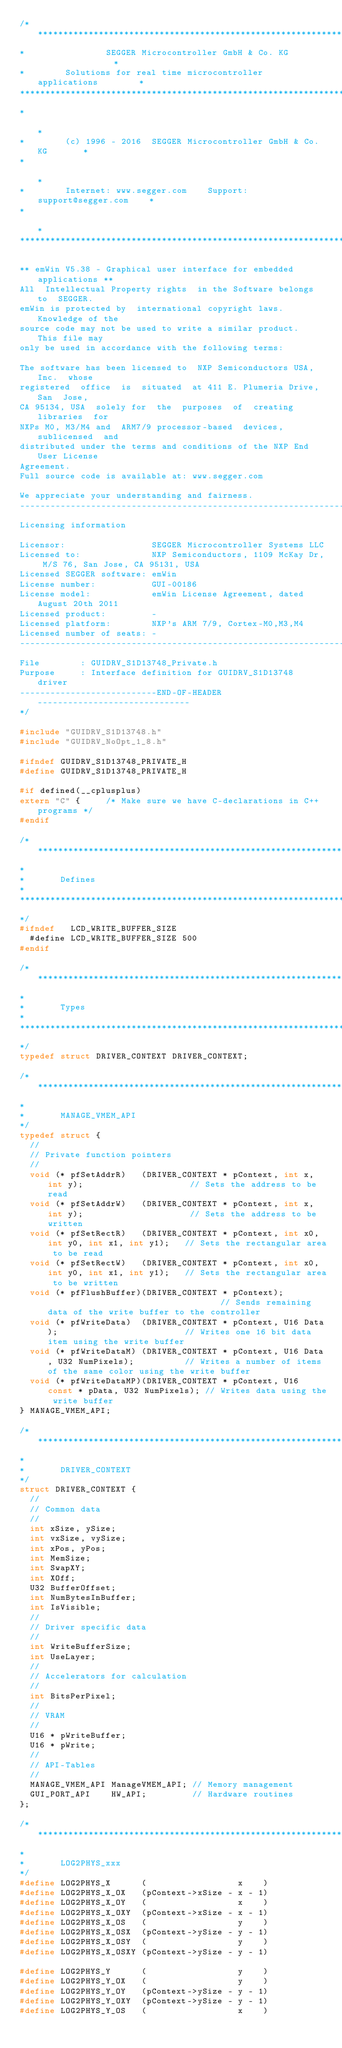<code> <loc_0><loc_0><loc_500><loc_500><_C_>/*********************************************************************
*                SEGGER Microcontroller GmbH & Co. KG                *
*        Solutions for real time microcontroller applications        *
**********************************************************************
*                                                                    *
*        (c) 1996 - 2016  SEGGER Microcontroller GmbH & Co. KG       *
*                                                                    *
*        Internet: www.segger.com    Support:  support@segger.com    *
*                                                                    *
**********************************************************************

** emWin V5.38 - Graphical user interface for embedded applications **
All  Intellectual Property rights  in the Software belongs to  SEGGER.
emWin is protected by  international copyright laws.  Knowledge of the
source code may not be used to write a similar product.  This file may
only be used in accordance with the following terms:

The software has been licensed to  NXP Semiconductors USA, Inc.  whose
registered  office  is  situated  at 411 E. Plumeria Drive, San  Jose,
CA 95134, USA  solely for  the  purposes  of  creating  libraries  for
NXPs M0, M3/M4 and  ARM7/9 processor-based  devices,  sublicensed  and
distributed under the terms and conditions of the NXP End User License
Agreement.
Full source code is available at: www.segger.com

We appreciate your understanding and fairness.
----------------------------------------------------------------------
Licensing information

Licensor:                 SEGGER Microcontroller Systems LLC
Licensed to:              NXP Semiconductors, 1109 McKay Dr, M/S 76, San Jose, CA 95131, USA
Licensed SEGGER software: emWin
License number:           GUI-00186
License model:            emWin License Agreement, dated August 20th 2011
Licensed product:         -
Licensed platform:        NXP's ARM 7/9, Cortex-M0,M3,M4
Licensed number of seats: -
----------------------------------------------------------------------
File        : GUIDRV_S1D13748_Private.h
Purpose     : Interface definition for GUIDRV_S1D13748 driver
---------------------------END-OF-HEADER------------------------------
*/

#include "GUIDRV_S1D13748.h"
#include "GUIDRV_NoOpt_1_8.h"

#ifndef GUIDRV_S1D13748_PRIVATE_H
#define GUIDRV_S1D13748_PRIVATE_H

#if defined(__cplusplus)
extern "C" {     /* Make sure we have C-declarations in C++ programs */
#endif

/*********************************************************************
*
*       Defines
*
**********************************************************************
*/
#ifndef   LCD_WRITE_BUFFER_SIZE
  #define LCD_WRITE_BUFFER_SIZE 500
#endif

/*********************************************************************
*
*       Types
*
**********************************************************************
*/
typedef struct DRIVER_CONTEXT DRIVER_CONTEXT;

/*********************************************************************
*
*       MANAGE_VMEM_API
*/
typedef struct {
  //
  // Private function pointers
  //
  void (* pfSetAddrR)   (DRIVER_CONTEXT * pContext, int x, int y);                     // Sets the address to be read
  void (* pfSetAddrW)   (DRIVER_CONTEXT * pContext, int x, int y);                     // Sets the address to be written
  void (* pfSetRectR)   (DRIVER_CONTEXT * pContext, int x0, int y0, int x1, int y1);   // Sets the rectangular area to be read
  void (* pfSetRectW)   (DRIVER_CONTEXT * pContext, int x0, int y0, int x1, int y1);   // Sets the rectangular area to be written
  void (* pfFlushBuffer)(DRIVER_CONTEXT * pContext);                                   // Sends remaining data of the write buffer to the controller
  void (* pfWriteData)  (DRIVER_CONTEXT * pContext, U16 Data);                         // Writes one 16 bit data item using the write buffer
  void (* pfWriteDataM) (DRIVER_CONTEXT * pContext, U16 Data, U32 NumPixels);          // Writes a number of items of the same color using the write buffer
  void (* pfWriteDataMP)(DRIVER_CONTEXT * pContext, U16 const * pData, U32 NumPixels); // Writes data using the write buffer
} MANAGE_VMEM_API;

/*********************************************************************
*
*       DRIVER_CONTEXT
*/
struct DRIVER_CONTEXT {
  //
  // Common data
  //
  int xSize, ySize;
  int vxSize, vySize;
  int xPos, yPos;
  int MemSize;
  int SwapXY;
  int XOff;
  U32 BufferOffset;
  int NumBytesInBuffer;
  int IsVisible;
  //
  // Driver specific data
  //
  int WriteBufferSize;
  int UseLayer;
  //
  // Accelerators for calculation
  //
  int BitsPerPixel;
  //
  // VRAM
  //
  U16 * pWriteBuffer;
  U16 * pWrite;
  //
  // API-Tables
  //
  MANAGE_VMEM_API ManageVMEM_API; // Memory management
  GUI_PORT_API    HW_API;         // Hardware routines
};

/*********************************************************************
*
*       LOG2PHYS_xxx
*/
#define LOG2PHYS_X      (                  x    )
#define LOG2PHYS_X_OX   (pContext->xSize - x - 1)
#define LOG2PHYS_X_OY   (                  x    )
#define LOG2PHYS_X_OXY  (pContext->xSize - x - 1)
#define LOG2PHYS_X_OS   (                  y    )
#define LOG2PHYS_X_OSX  (pContext->ySize - y - 1)
#define LOG2PHYS_X_OSY  (                  y    )
#define LOG2PHYS_X_OSXY (pContext->ySize - y - 1)

#define LOG2PHYS_Y      (                  y    )
#define LOG2PHYS_Y_OX   (                  y    )
#define LOG2PHYS_Y_OY   (pContext->ySize - y - 1)
#define LOG2PHYS_Y_OXY  (pContext->ySize - y - 1)
#define LOG2PHYS_Y_OS   (                  x    )</code> 